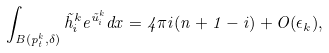Convert formula to latex. <formula><loc_0><loc_0><loc_500><loc_500>\int _ { B ( p _ { t } ^ { k } , \delta ) } \tilde { h } _ { i } ^ { k } e ^ { \tilde { u } _ { i } ^ { k } } d x = 4 \pi i ( n + 1 - i ) + O ( \epsilon _ { k } ) ,</formula> 